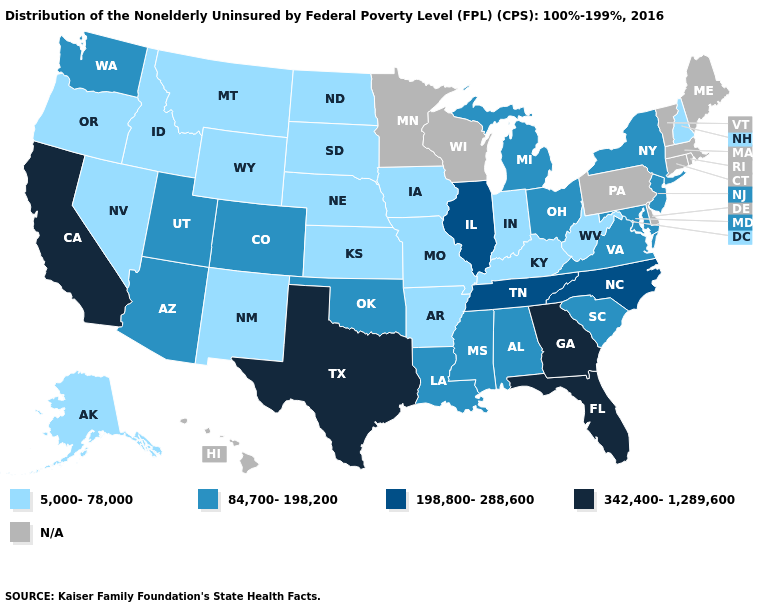Does Kansas have the highest value in the USA?
Short answer required. No. Is the legend a continuous bar?
Answer briefly. No. What is the value of Maryland?
Write a very short answer. 84,700-198,200. What is the value of South Dakota?
Short answer required. 5,000-78,000. Which states have the lowest value in the South?
Short answer required. Arkansas, Kentucky, West Virginia. Name the states that have a value in the range 342,400-1,289,600?
Give a very brief answer. California, Florida, Georgia, Texas. Which states hav the highest value in the Northeast?
Quick response, please. New Jersey, New York. Does Montana have the lowest value in the USA?
Be succinct. Yes. What is the highest value in states that border Florida?
Concise answer only. 342,400-1,289,600. Among the states that border Indiana , which have the highest value?
Be succinct. Illinois. What is the value of North Dakota?
Answer briefly. 5,000-78,000. Name the states that have a value in the range N/A?
Quick response, please. Connecticut, Delaware, Hawaii, Maine, Massachusetts, Minnesota, Pennsylvania, Rhode Island, Vermont, Wisconsin. Name the states that have a value in the range 342,400-1,289,600?
Quick response, please. California, Florida, Georgia, Texas. 